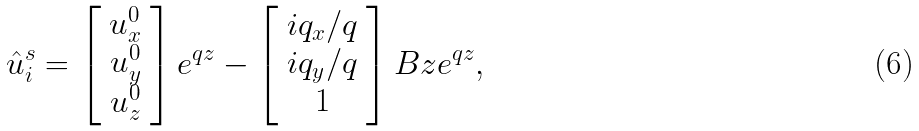<formula> <loc_0><loc_0><loc_500><loc_500>\hat { u } ^ { s } _ { i } = \left [ \begin{array} { c } u _ { x } ^ { 0 } \\ u _ { y } ^ { 0 } \\ u _ { z } ^ { 0 } \end{array} \right ] e ^ { q z } - \left [ \begin{array} { c } i q _ { x } / q \\ i q _ { y } / q \\ 1 \end{array} \right ] B z e ^ { q z } ,</formula> 